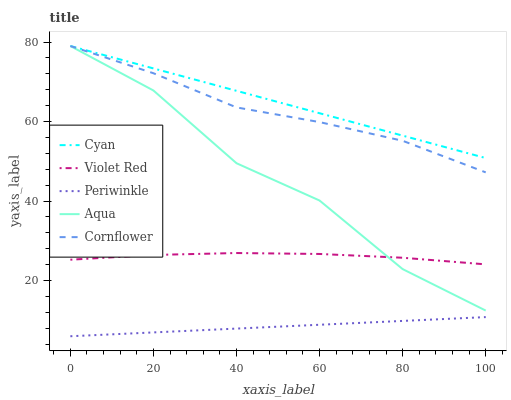Does Periwinkle have the minimum area under the curve?
Answer yes or no. Yes. Does Cyan have the maximum area under the curve?
Answer yes or no. Yes. Does Violet Red have the minimum area under the curve?
Answer yes or no. No. Does Violet Red have the maximum area under the curve?
Answer yes or no. No. Is Periwinkle the smoothest?
Answer yes or no. Yes. Is Aqua the roughest?
Answer yes or no. Yes. Is Cyan the smoothest?
Answer yes or no. No. Is Cyan the roughest?
Answer yes or no. No. Does Periwinkle have the lowest value?
Answer yes or no. Yes. Does Violet Red have the lowest value?
Answer yes or no. No. Does Cornflower have the highest value?
Answer yes or no. Yes. Does Violet Red have the highest value?
Answer yes or no. No. Is Periwinkle less than Cornflower?
Answer yes or no. Yes. Is Cyan greater than Periwinkle?
Answer yes or no. Yes. Does Violet Red intersect Aqua?
Answer yes or no. Yes. Is Violet Red less than Aqua?
Answer yes or no. No. Is Violet Red greater than Aqua?
Answer yes or no. No. Does Periwinkle intersect Cornflower?
Answer yes or no. No. 